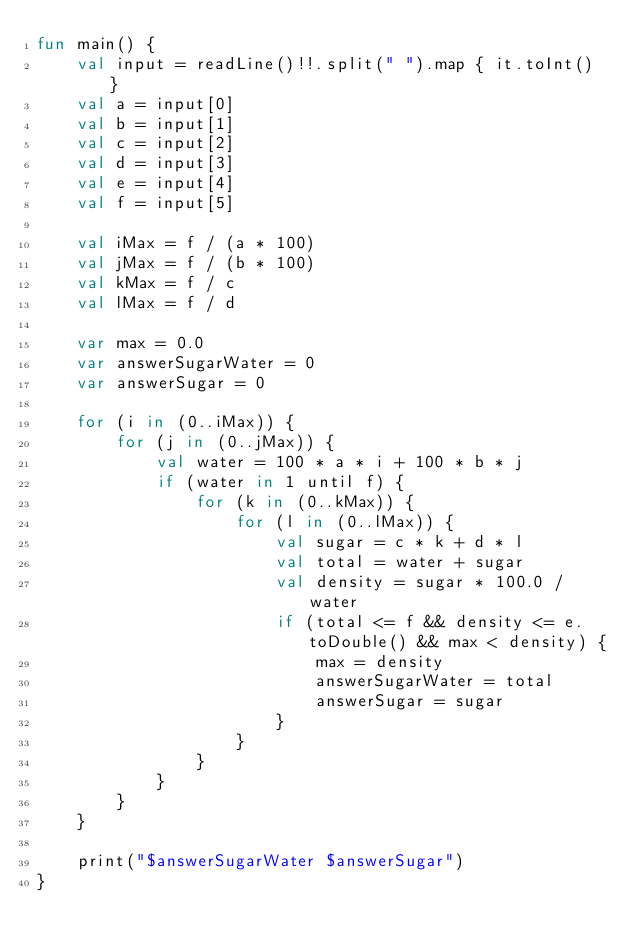Convert code to text. <code><loc_0><loc_0><loc_500><loc_500><_Kotlin_>fun main() {
    val input = readLine()!!.split(" ").map { it.toInt() }
    val a = input[0]
    val b = input[1]
    val c = input[2]
    val d = input[3]
    val e = input[4]
    val f = input[5]

    val iMax = f / (a * 100)
    val jMax = f / (b * 100)
    val kMax = f / c
    val lMax = f / d

    var max = 0.0
    var answerSugarWater = 0
    var answerSugar = 0

    for (i in (0..iMax)) {
        for (j in (0..jMax)) {
            val water = 100 * a * i + 100 * b * j
            if (water in 1 until f) {
                for (k in (0..kMax)) {
                    for (l in (0..lMax)) {
                        val sugar = c * k + d * l
                        val total = water + sugar
                        val density = sugar * 100.0 / water
                        if (total <= f && density <= e.toDouble() && max < density) {
                            max = density
                            answerSugarWater = total
                            answerSugar = sugar
                        }
                    }
                }
            }
        }
    }

    print("$answerSugarWater $answerSugar")
}


</code> 